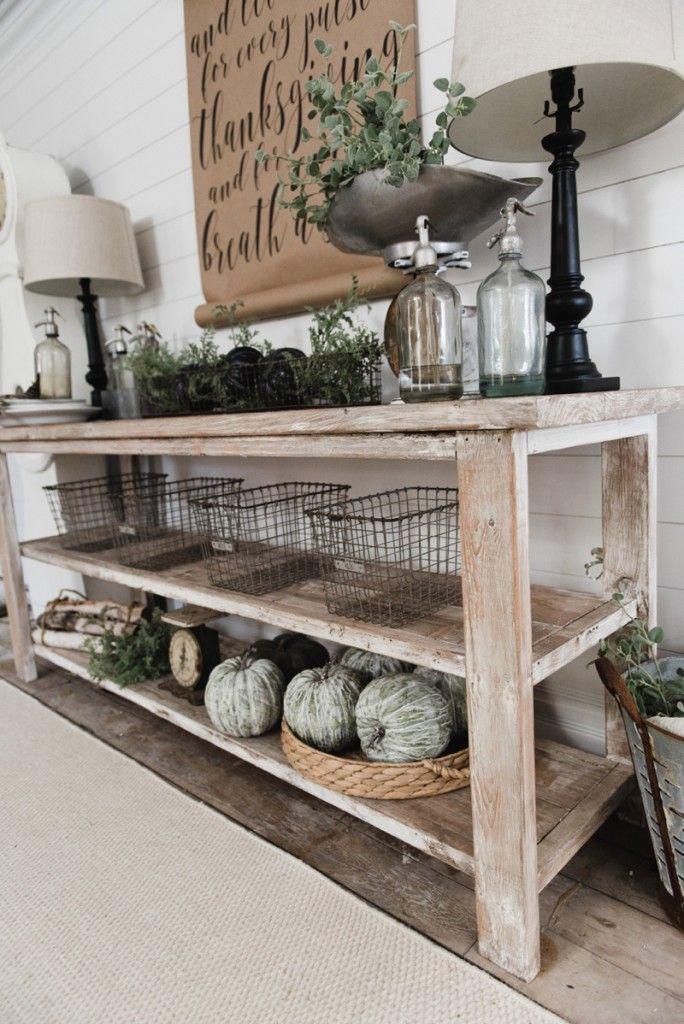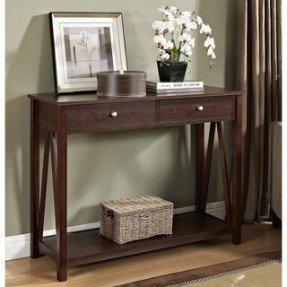The first image is the image on the left, the second image is the image on the right. For the images shown, is this caption "A TV with a black screen is hanging on a white wall." true? Answer yes or no. No. 